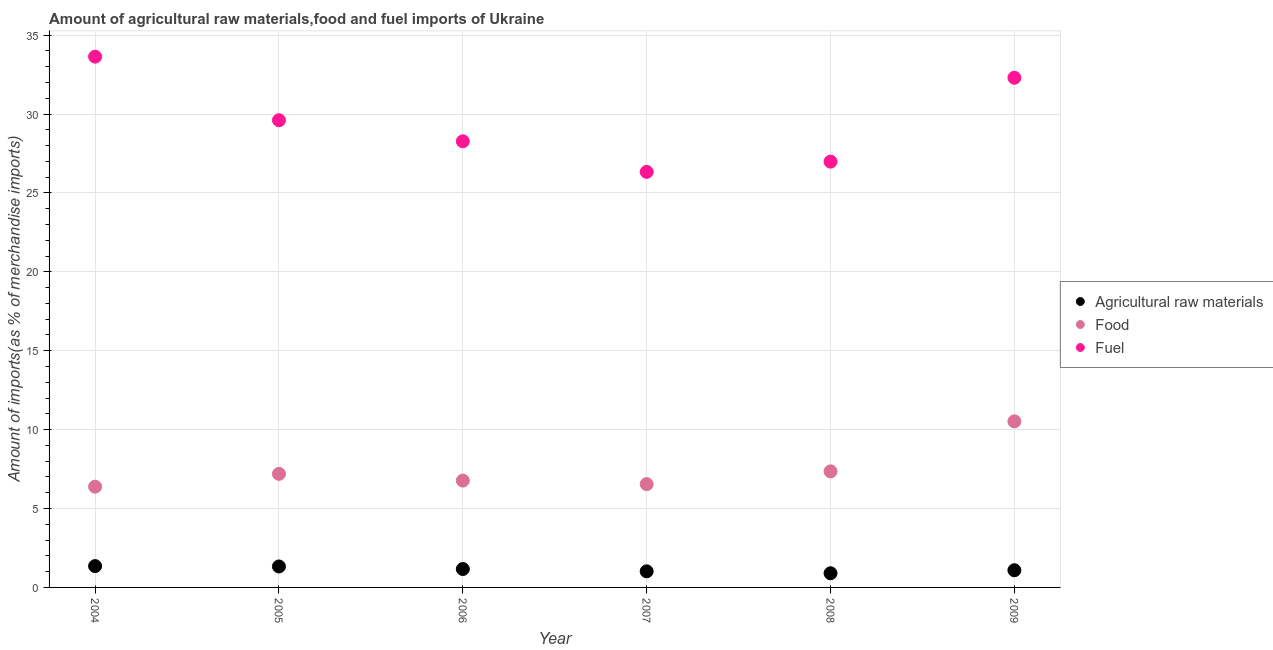What is the percentage of raw materials imports in 2006?
Keep it short and to the point. 1.17. Across all years, what is the maximum percentage of fuel imports?
Your response must be concise. 33.64. Across all years, what is the minimum percentage of food imports?
Ensure brevity in your answer.  6.39. In which year was the percentage of fuel imports maximum?
Make the answer very short. 2004. In which year was the percentage of fuel imports minimum?
Offer a very short reply. 2007. What is the total percentage of raw materials imports in the graph?
Give a very brief answer. 6.86. What is the difference between the percentage of fuel imports in 2006 and that in 2008?
Provide a succinct answer. 1.29. What is the difference between the percentage of fuel imports in 2006 and the percentage of food imports in 2004?
Offer a terse response. 21.89. What is the average percentage of fuel imports per year?
Make the answer very short. 29.52. In the year 2004, what is the difference between the percentage of food imports and percentage of fuel imports?
Give a very brief answer. -27.25. In how many years, is the percentage of food imports greater than 13 %?
Provide a succinct answer. 0. What is the ratio of the percentage of fuel imports in 2008 to that in 2009?
Your answer should be compact. 0.84. Is the percentage of fuel imports in 2008 less than that in 2009?
Offer a very short reply. Yes. What is the difference between the highest and the second highest percentage of raw materials imports?
Offer a very short reply. 0.02. What is the difference between the highest and the lowest percentage of fuel imports?
Ensure brevity in your answer.  7.3. Is the sum of the percentage of raw materials imports in 2007 and 2009 greater than the maximum percentage of fuel imports across all years?
Provide a succinct answer. No. Is it the case that in every year, the sum of the percentage of raw materials imports and percentage of food imports is greater than the percentage of fuel imports?
Provide a short and direct response. No. Does the percentage of raw materials imports monotonically increase over the years?
Make the answer very short. No. Is the percentage of raw materials imports strictly greater than the percentage of fuel imports over the years?
Ensure brevity in your answer.  No. Is the percentage of raw materials imports strictly less than the percentage of food imports over the years?
Offer a terse response. Yes. How many years are there in the graph?
Your response must be concise. 6. Does the graph contain any zero values?
Provide a succinct answer. No. Does the graph contain grids?
Ensure brevity in your answer.  Yes. Where does the legend appear in the graph?
Your answer should be very brief. Center right. How are the legend labels stacked?
Provide a succinct answer. Vertical. What is the title of the graph?
Ensure brevity in your answer.  Amount of agricultural raw materials,food and fuel imports of Ukraine. What is the label or title of the X-axis?
Make the answer very short. Year. What is the label or title of the Y-axis?
Provide a short and direct response. Amount of imports(as % of merchandise imports). What is the Amount of imports(as % of merchandise imports) in Agricultural raw materials in 2004?
Provide a short and direct response. 1.35. What is the Amount of imports(as % of merchandise imports) in Food in 2004?
Your response must be concise. 6.39. What is the Amount of imports(as % of merchandise imports) of Fuel in 2004?
Offer a terse response. 33.64. What is the Amount of imports(as % of merchandise imports) in Agricultural raw materials in 2005?
Provide a short and direct response. 1.33. What is the Amount of imports(as % of merchandise imports) of Food in 2005?
Offer a very short reply. 7.2. What is the Amount of imports(as % of merchandise imports) in Fuel in 2005?
Provide a short and direct response. 29.61. What is the Amount of imports(as % of merchandise imports) in Agricultural raw materials in 2006?
Offer a very short reply. 1.17. What is the Amount of imports(as % of merchandise imports) in Food in 2006?
Your answer should be compact. 6.77. What is the Amount of imports(as % of merchandise imports) of Fuel in 2006?
Your response must be concise. 28.27. What is the Amount of imports(as % of merchandise imports) of Agricultural raw materials in 2007?
Ensure brevity in your answer.  1.02. What is the Amount of imports(as % of merchandise imports) in Food in 2007?
Your answer should be very brief. 6.55. What is the Amount of imports(as % of merchandise imports) in Fuel in 2007?
Your answer should be compact. 26.33. What is the Amount of imports(as % of merchandise imports) of Agricultural raw materials in 2008?
Your response must be concise. 0.9. What is the Amount of imports(as % of merchandise imports) in Food in 2008?
Your answer should be very brief. 7.35. What is the Amount of imports(as % of merchandise imports) of Fuel in 2008?
Your answer should be very brief. 26.98. What is the Amount of imports(as % of merchandise imports) of Agricultural raw materials in 2009?
Your answer should be compact. 1.09. What is the Amount of imports(as % of merchandise imports) of Food in 2009?
Offer a very short reply. 10.52. What is the Amount of imports(as % of merchandise imports) in Fuel in 2009?
Your answer should be compact. 32.3. Across all years, what is the maximum Amount of imports(as % of merchandise imports) of Agricultural raw materials?
Offer a very short reply. 1.35. Across all years, what is the maximum Amount of imports(as % of merchandise imports) of Food?
Offer a very short reply. 10.52. Across all years, what is the maximum Amount of imports(as % of merchandise imports) in Fuel?
Provide a short and direct response. 33.64. Across all years, what is the minimum Amount of imports(as % of merchandise imports) of Agricultural raw materials?
Ensure brevity in your answer.  0.9. Across all years, what is the minimum Amount of imports(as % of merchandise imports) in Food?
Provide a short and direct response. 6.39. Across all years, what is the minimum Amount of imports(as % of merchandise imports) of Fuel?
Ensure brevity in your answer.  26.33. What is the total Amount of imports(as % of merchandise imports) of Agricultural raw materials in the graph?
Offer a very short reply. 6.86. What is the total Amount of imports(as % of merchandise imports) in Food in the graph?
Your answer should be compact. 44.78. What is the total Amount of imports(as % of merchandise imports) in Fuel in the graph?
Your answer should be compact. 177.13. What is the difference between the Amount of imports(as % of merchandise imports) of Agricultural raw materials in 2004 and that in 2005?
Give a very brief answer. 0.02. What is the difference between the Amount of imports(as % of merchandise imports) of Food in 2004 and that in 2005?
Offer a terse response. -0.81. What is the difference between the Amount of imports(as % of merchandise imports) of Fuel in 2004 and that in 2005?
Your response must be concise. 4.03. What is the difference between the Amount of imports(as % of merchandise imports) in Agricultural raw materials in 2004 and that in 2006?
Provide a short and direct response. 0.18. What is the difference between the Amount of imports(as % of merchandise imports) of Food in 2004 and that in 2006?
Provide a short and direct response. -0.39. What is the difference between the Amount of imports(as % of merchandise imports) in Fuel in 2004 and that in 2006?
Offer a very short reply. 5.36. What is the difference between the Amount of imports(as % of merchandise imports) of Agricultural raw materials in 2004 and that in 2007?
Ensure brevity in your answer.  0.33. What is the difference between the Amount of imports(as % of merchandise imports) in Food in 2004 and that in 2007?
Your answer should be very brief. -0.16. What is the difference between the Amount of imports(as % of merchandise imports) in Fuel in 2004 and that in 2007?
Give a very brief answer. 7.3. What is the difference between the Amount of imports(as % of merchandise imports) of Agricultural raw materials in 2004 and that in 2008?
Ensure brevity in your answer.  0.45. What is the difference between the Amount of imports(as % of merchandise imports) of Food in 2004 and that in 2008?
Your answer should be very brief. -0.97. What is the difference between the Amount of imports(as % of merchandise imports) in Fuel in 2004 and that in 2008?
Keep it short and to the point. 6.65. What is the difference between the Amount of imports(as % of merchandise imports) of Agricultural raw materials in 2004 and that in 2009?
Your answer should be very brief. 0.26. What is the difference between the Amount of imports(as % of merchandise imports) in Food in 2004 and that in 2009?
Your answer should be compact. -4.14. What is the difference between the Amount of imports(as % of merchandise imports) in Fuel in 2004 and that in 2009?
Your answer should be compact. 1.34. What is the difference between the Amount of imports(as % of merchandise imports) of Agricultural raw materials in 2005 and that in 2006?
Give a very brief answer. 0.16. What is the difference between the Amount of imports(as % of merchandise imports) of Food in 2005 and that in 2006?
Offer a very short reply. 0.43. What is the difference between the Amount of imports(as % of merchandise imports) of Fuel in 2005 and that in 2006?
Your answer should be compact. 1.34. What is the difference between the Amount of imports(as % of merchandise imports) of Agricultural raw materials in 2005 and that in 2007?
Your answer should be very brief. 0.31. What is the difference between the Amount of imports(as % of merchandise imports) in Food in 2005 and that in 2007?
Your answer should be compact. 0.65. What is the difference between the Amount of imports(as % of merchandise imports) in Fuel in 2005 and that in 2007?
Your answer should be compact. 3.27. What is the difference between the Amount of imports(as % of merchandise imports) in Agricultural raw materials in 2005 and that in 2008?
Your response must be concise. 0.43. What is the difference between the Amount of imports(as % of merchandise imports) of Food in 2005 and that in 2008?
Your answer should be very brief. -0.16. What is the difference between the Amount of imports(as % of merchandise imports) of Fuel in 2005 and that in 2008?
Offer a terse response. 2.62. What is the difference between the Amount of imports(as % of merchandise imports) in Agricultural raw materials in 2005 and that in 2009?
Ensure brevity in your answer.  0.24. What is the difference between the Amount of imports(as % of merchandise imports) in Food in 2005 and that in 2009?
Offer a terse response. -3.33. What is the difference between the Amount of imports(as % of merchandise imports) in Fuel in 2005 and that in 2009?
Your answer should be very brief. -2.69. What is the difference between the Amount of imports(as % of merchandise imports) of Agricultural raw materials in 2006 and that in 2007?
Give a very brief answer. 0.15. What is the difference between the Amount of imports(as % of merchandise imports) in Food in 2006 and that in 2007?
Make the answer very short. 0.22. What is the difference between the Amount of imports(as % of merchandise imports) in Fuel in 2006 and that in 2007?
Offer a terse response. 1.94. What is the difference between the Amount of imports(as % of merchandise imports) of Agricultural raw materials in 2006 and that in 2008?
Offer a terse response. 0.27. What is the difference between the Amount of imports(as % of merchandise imports) of Food in 2006 and that in 2008?
Your response must be concise. -0.58. What is the difference between the Amount of imports(as % of merchandise imports) of Fuel in 2006 and that in 2008?
Offer a terse response. 1.29. What is the difference between the Amount of imports(as % of merchandise imports) of Agricultural raw materials in 2006 and that in 2009?
Keep it short and to the point. 0.08. What is the difference between the Amount of imports(as % of merchandise imports) in Food in 2006 and that in 2009?
Keep it short and to the point. -3.75. What is the difference between the Amount of imports(as % of merchandise imports) of Fuel in 2006 and that in 2009?
Your response must be concise. -4.03. What is the difference between the Amount of imports(as % of merchandise imports) in Agricultural raw materials in 2007 and that in 2008?
Provide a succinct answer. 0.12. What is the difference between the Amount of imports(as % of merchandise imports) in Food in 2007 and that in 2008?
Your answer should be very brief. -0.81. What is the difference between the Amount of imports(as % of merchandise imports) in Fuel in 2007 and that in 2008?
Ensure brevity in your answer.  -0.65. What is the difference between the Amount of imports(as % of merchandise imports) of Agricultural raw materials in 2007 and that in 2009?
Give a very brief answer. -0.07. What is the difference between the Amount of imports(as % of merchandise imports) of Food in 2007 and that in 2009?
Offer a very short reply. -3.98. What is the difference between the Amount of imports(as % of merchandise imports) of Fuel in 2007 and that in 2009?
Your answer should be compact. -5.96. What is the difference between the Amount of imports(as % of merchandise imports) of Agricultural raw materials in 2008 and that in 2009?
Offer a very short reply. -0.19. What is the difference between the Amount of imports(as % of merchandise imports) of Food in 2008 and that in 2009?
Make the answer very short. -3.17. What is the difference between the Amount of imports(as % of merchandise imports) in Fuel in 2008 and that in 2009?
Provide a short and direct response. -5.31. What is the difference between the Amount of imports(as % of merchandise imports) of Agricultural raw materials in 2004 and the Amount of imports(as % of merchandise imports) of Food in 2005?
Your response must be concise. -5.85. What is the difference between the Amount of imports(as % of merchandise imports) in Agricultural raw materials in 2004 and the Amount of imports(as % of merchandise imports) in Fuel in 2005?
Provide a succinct answer. -28.26. What is the difference between the Amount of imports(as % of merchandise imports) of Food in 2004 and the Amount of imports(as % of merchandise imports) of Fuel in 2005?
Your answer should be very brief. -23.22. What is the difference between the Amount of imports(as % of merchandise imports) in Agricultural raw materials in 2004 and the Amount of imports(as % of merchandise imports) in Food in 2006?
Make the answer very short. -5.42. What is the difference between the Amount of imports(as % of merchandise imports) of Agricultural raw materials in 2004 and the Amount of imports(as % of merchandise imports) of Fuel in 2006?
Make the answer very short. -26.92. What is the difference between the Amount of imports(as % of merchandise imports) in Food in 2004 and the Amount of imports(as % of merchandise imports) in Fuel in 2006?
Provide a succinct answer. -21.89. What is the difference between the Amount of imports(as % of merchandise imports) of Agricultural raw materials in 2004 and the Amount of imports(as % of merchandise imports) of Food in 2007?
Your answer should be very brief. -5.2. What is the difference between the Amount of imports(as % of merchandise imports) in Agricultural raw materials in 2004 and the Amount of imports(as % of merchandise imports) in Fuel in 2007?
Your response must be concise. -24.98. What is the difference between the Amount of imports(as % of merchandise imports) in Food in 2004 and the Amount of imports(as % of merchandise imports) in Fuel in 2007?
Give a very brief answer. -19.95. What is the difference between the Amount of imports(as % of merchandise imports) in Agricultural raw materials in 2004 and the Amount of imports(as % of merchandise imports) in Food in 2008?
Provide a succinct answer. -6. What is the difference between the Amount of imports(as % of merchandise imports) of Agricultural raw materials in 2004 and the Amount of imports(as % of merchandise imports) of Fuel in 2008?
Keep it short and to the point. -25.63. What is the difference between the Amount of imports(as % of merchandise imports) of Food in 2004 and the Amount of imports(as % of merchandise imports) of Fuel in 2008?
Keep it short and to the point. -20.6. What is the difference between the Amount of imports(as % of merchandise imports) in Agricultural raw materials in 2004 and the Amount of imports(as % of merchandise imports) in Food in 2009?
Your answer should be compact. -9.17. What is the difference between the Amount of imports(as % of merchandise imports) of Agricultural raw materials in 2004 and the Amount of imports(as % of merchandise imports) of Fuel in 2009?
Give a very brief answer. -30.95. What is the difference between the Amount of imports(as % of merchandise imports) of Food in 2004 and the Amount of imports(as % of merchandise imports) of Fuel in 2009?
Offer a terse response. -25.91. What is the difference between the Amount of imports(as % of merchandise imports) in Agricultural raw materials in 2005 and the Amount of imports(as % of merchandise imports) in Food in 2006?
Provide a short and direct response. -5.44. What is the difference between the Amount of imports(as % of merchandise imports) in Agricultural raw materials in 2005 and the Amount of imports(as % of merchandise imports) in Fuel in 2006?
Provide a succinct answer. -26.94. What is the difference between the Amount of imports(as % of merchandise imports) of Food in 2005 and the Amount of imports(as % of merchandise imports) of Fuel in 2006?
Ensure brevity in your answer.  -21.07. What is the difference between the Amount of imports(as % of merchandise imports) of Agricultural raw materials in 2005 and the Amount of imports(as % of merchandise imports) of Food in 2007?
Make the answer very short. -5.22. What is the difference between the Amount of imports(as % of merchandise imports) in Agricultural raw materials in 2005 and the Amount of imports(as % of merchandise imports) in Fuel in 2007?
Provide a short and direct response. -25. What is the difference between the Amount of imports(as % of merchandise imports) in Food in 2005 and the Amount of imports(as % of merchandise imports) in Fuel in 2007?
Your answer should be compact. -19.14. What is the difference between the Amount of imports(as % of merchandise imports) of Agricultural raw materials in 2005 and the Amount of imports(as % of merchandise imports) of Food in 2008?
Ensure brevity in your answer.  -6.03. What is the difference between the Amount of imports(as % of merchandise imports) in Agricultural raw materials in 2005 and the Amount of imports(as % of merchandise imports) in Fuel in 2008?
Give a very brief answer. -25.66. What is the difference between the Amount of imports(as % of merchandise imports) of Food in 2005 and the Amount of imports(as % of merchandise imports) of Fuel in 2008?
Your answer should be compact. -19.79. What is the difference between the Amount of imports(as % of merchandise imports) in Agricultural raw materials in 2005 and the Amount of imports(as % of merchandise imports) in Food in 2009?
Ensure brevity in your answer.  -9.2. What is the difference between the Amount of imports(as % of merchandise imports) of Agricultural raw materials in 2005 and the Amount of imports(as % of merchandise imports) of Fuel in 2009?
Make the answer very short. -30.97. What is the difference between the Amount of imports(as % of merchandise imports) of Food in 2005 and the Amount of imports(as % of merchandise imports) of Fuel in 2009?
Your response must be concise. -25.1. What is the difference between the Amount of imports(as % of merchandise imports) in Agricultural raw materials in 2006 and the Amount of imports(as % of merchandise imports) in Food in 2007?
Give a very brief answer. -5.38. What is the difference between the Amount of imports(as % of merchandise imports) of Agricultural raw materials in 2006 and the Amount of imports(as % of merchandise imports) of Fuel in 2007?
Make the answer very short. -25.17. What is the difference between the Amount of imports(as % of merchandise imports) in Food in 2006 and the Amount of imports(as % of merchandise imports) in Fuel in 2007?
Provide a succinct answer. -19.56. What is the difference between the Amount of imports(as % of merchandise imports) in Agricultural raw materials in 2006 and the Amount of imports(as % of merchandise imports) in Food in 2008?
Keep it short and to the point. -6.19. What is the difference between the Amount of imports(as % of merchandise imports) in Agricultural raw materials in 2006 and the Amount of imports(as % of merchandise imports) in Fuel in 2008?
Your answer should be very brief. -25.82. What is the difference between the Amount of imports(as % of merchandise imports) of Food in 2006 and the Amount of imports(as % of merchandise imports) of Fuel in 2008?
Ensure brevity in your answer.  -20.21. What is the difference between the Amount of imports(as % of merchandise imports) of Agricultural raw materials in 2006 and the Amount of imports(as % of merchandise imports) of Food in 2009?
Your response must be concise. -9.36. What is the difference between the Amount of imports(as % of merchandise imports) of Agricultural raw materials in 2006 and the Amount of imports(as % of merchandise imports) of Fuel in 2009?
Offer a very short reply. -31.13. What is the difference between the Amount of imports(as % of merchandise imports) of Food in 2006 and the Amount of imports(as % of merchandise imports) of Fuel in 2009?
Your response must be concise. -25.53. What is the difference between the Amount of imports(as % of merchandise imports) of Agricultural raw materials in 2007 and the Amount of imports(as % of merchandise imports) of Food in 2008?
Your response must be concise. -6.33. What is the difference between the Amount of imports(as % of merchandise imports) of Agricultural raw materials in 2007 and the Amount of imports(as % of merchandise imports) of Fuel in 2008?
Offer a terse response. -25.96. What is the difference between the Amount of imports(as % of merchandise imports) of Food in 2007 and the Amount of imports(as % of merchandise imports) of Fuel in 2008?
Your answer should be compact. -20.44. What is the difference between the Amount of imports(as % of merchandise imports) in Agricultural raw materials in 2007 and the Amount of imports(as % of merchandise imports) in Food in 2009?
Give a very brief answer. -9.5. What is the difference between the Amount of imports(as % of merchandise imports) in Agricultural raw materials in 2007 and the Amount of imports(as % of merchandise imports) in Fuel in 2009?
Provide a short and direct response. -31.28. What is the difference between the Amount of imports(as % of merchandise imports) in Food in 2007 and the Amount of imports(as % of merchandise imports) in Fuel in 2009?
Your response must be concise. -25.75. What is the difference between the Amount of imports(as % of merchandise imports) of Agricultural raw materials in 2008 and the Amount of imports(as % of merchandise imports) of Food in 2009?
Provide a short and direct response. -9.63. What is the difference between the Amount of imports(as % of merchandise imports) in Agricultural raw materials in 2008 and the Amount of imports(as % of merchandise imports) in Fuel in 2009?
Provide a succinct answer. -31.4. What is the difference between the Amount of imports(as % of merchandise imports) of Food in 2008 and the Amount of imports(as % of merchandise imports) of Fuel in 2009?
Your answer should be very brief. -24.94. What is the average Amount of imports(as % of merchandise imports) of Agricultural raw materials per year?
Provide a short and direct response. 1.14. What is the average Amount of imports(as % of merchandise imports) in Food per year?
Offer a very short reply. 7.46. What is the average Amount of imports(as % of merchandise imports) in Fuel per year?
Give a very brief answer. 29.52. In the year 2004, what is the difference between the Amount of imports(as % of merchandise imports) in Agricultural raw materials and Amount of imports(as % of merchandise imports) in Food?
Provide a succinct answer. -5.03. In the year 2004, what is the difference between the Amount of imports(as % of merchandise imports) of Agricultural raw materials and Amount of imports(as % of merchandise imports) of Fuel?
Offer a very short reply. -32.28. In the year 2004, what is the difference between the Amount of imports(as % of merchandise imports) in Food and Amount of imports(as % of merchandise imports) in Fuel?
Your response must be concise. -27.25. In the year 2005, what is the difference between the Amount of imports(as % of merchandise imports) of Agricultural raw materials and Amount of imports(as % of merchandise imports) of Food?
Provide a short and direct response. -5.87. In the year 2005, what is the difference between the Amount of imports(as % of merchandise imports) of Agricultural raw materials and Amount of imports(as % of merchandise imports) of Fuel?
Keep it short and to the point. -28.28. In the year 2005, what is the difference between the Amount of imports(as % of merchandise imports) in Food and Amount of imports(as % of merchandise imports) in Fuel?
Offer a terse response. -22.41. In the year 2006, what is the difference between the Amount of imports(as % of merchandise imports) in Agricultural raw materials and Amount of imports(as % of merchandise imports) in Food?
Your response must be concise. -5.6. In the year 2006, what is the difference between the Amount of imports(as % of merchandise imports) in Agricultural raw materials and Amount of imports(as % of merchandise imports) in Fuel?
Your response must be concise. -27.1. In the year 2006, what is the difference between the Amount of imports(as % of merchandise imports) in Food and Amount of imports(as % of merchandise imports) in Fuel?
Offer a very short reply. -21.5. In the year 2007, what is the difference between the Amount of imports(as % of merchandise imports) of Agricultural raw materials and Amount of imports(as % of merchandise imports) of Food?
Give a very brief answer. -5.53. In the year 2007, what is the difference between the Amount of imports(as % of merchandise imports) in Agricultural raw materials and Amount of imports(as % of merchandise imports) in Fuel?
Your response must be concise. -25.31. In the year 2007, what is the difference between the Amount of imports(as % of merchandise imports) of Food and Amount of imports(as % of merchandise imports) of Fuel?
Your answer should be compact. -19.79. In the year 2008, what is the difference between the Amount of imports(as % of merchandise imports) of Agricultural raw materials and Amount of imports(as % of merchandise imports) of Food?
Your answer should be compact. -6.46. In the year 2008, what is the difference between the Amount of imports(as % of merchandise imports) of Agricultural raw materials and Amount of imports(as % of merchandise imports) of Fuel?
Keep it short and to the point. -26.08. In the year 2008, what is the difference between the Amount of imports(as % of merchandise imports) in Food and Amount of imports(as % of merchandise imports) in Fuel?
Make the answer very short. -19.63. In the year 2009, what is the difference between the Amount of imports(as % of merchandise imports) of Agricultural raw materials and Amount of imports(as % of merchandise imports) of Food?
Offer a terse response. -9.43. In the year 2009, what is the difference between the Amount of imports(as % of merchandise imports) of Agricultural raw materials and Amount of imports(as % of merchandise imports) of Fuel?
Keep it short and to the point. -31.21. In the year 2009, what is the difference between the Amount of imports(as % of merchandise imports) in Food and Amount of imports(as % of merchandise imports) in Fuel?
Your answer should be very brief. -21.77. What is the ratio of the Amount of imports(as % of merchandise imports) in Agricultural raw materials in 2004 to that in 2005?
Your response must be concise. 1.02. What is the ratio of the Amount of imports(as % of merchandise imports) of Food in 2004 to that in 2005?
Your answer should be very brief. 0.89. What is the ratio of the Amount of imports(as % of merchandise imports) in Fuel in 2004 to that in 2005?
Give a very brief answer. 1.14. What is the ratio of the Amount of imports(as % of merchandise imports) in Agricultural raw materials in 2004 to that in 2006?
Give a very brief answer. 1.16. What is the ratio of the Amount of imports(as % of merchandise imports) in Food in 2004 to that in 2006?
Give a very brief answer. 0.94. What is the ratio of the Amount of imports(as % of merchandise imports) in Fuel in 2004 to that in 2006?
Offer a terse response. 1.19. What is the ratio of the Amount of imports(as % of merchandise imports) of Agricultural raw materials in 2004 to that in 2007?
Offer a very short reply. 1.32. What is the ratio of the Amount of imports(as % of merchandise imports) in Food in 2004 to that in 2007?
Your response must be concise. 0.98. What is the ratio of the Amount of imports(as % of merchandise imports) in Fuel in 2004 to that in 2007?
Your response must be concise. 1.28. What is the ratio of the Amount of imports(as % of merchandise imports) of Agricultural raw materials in 2004 to that in 2008?
Ensure brevity in your answer.  1.5. What is the ratio of the Amount of imports(as % of merchandise imports) of Food in 2004 to that in 2008?
Your response must be concise. 0.87. What is the ratio of the Amount of imports(as % of merchandise imports) of Fuel in 2004 to that in 2008?
Your response must be concise. 1.25. What is the ratio of the Amount of imports(as % of merchandise imports) in Agricultural raw materials in 2004 to that in 2009?
Provide a succinct answer. 1.24. What is the ratio of the Amount of imports(as % of merchandise imports) of Food in 2004 to that in 2009?
Provide a succinct answer. 0.61. What is the ratio of the Amount of imports(as % of merchandise imports) in Fuel in 2004 to that in 2009?
Your response must be concise. 1.04. What is the ratio of the Amount of imports(as % of merchandise imports) of Agricultural raw materials in 2005 to that in 2006?
Offer a terse response. 1.14. What is the ratio of the Amount of imports(as % of merchandise imports) in Food in 2005 to that in 2006?
Keep it short and to the point. 1.06. What is the ratio of the Amount of imports(as % of merchandise imports) of Fuel in 2005 to that in 2006?
Your response must be concise. 1.05. What is the ratio of the Amount of imports(as % of merchandise imports) in Agricultural raw materials in 2005 to that in 2007?
Provide a succinct answer. 1.3. What is the ratio of the Amount of imports(as % of merchandise imports) in Food in 2005 to that in 2007?
Your answer should be compact. 1.1. What is the ratio of the Amount of imports(as % of merchandise imports) in Fuel in 2005 to that in 2007?
Provide a short and direct response. 1.12. What is the ratio of the Amount of imports(as % of merchandise imports) of Agricultural raw materials in 2005 to that in 2008?
Your answer should be very brief. 1.48. What is the ratio of the Amount of imports(as % of merchandise imports) in Food in 2005 to that in 2008?
Offer a very short reply. 0.98. What is the ratio of the Amount of imports(as % of merchandise imports) of Fuel in 2005 to that in 2008?
Keep it short and to the point. 1.1. What is the ratio of the Amount of imports(as % of merchandise imports) of Agricultural raw materials in 2005 to that in 2009?
Your response must be concise. 1.22. What is the ratio of the Amount of imports(as % of merchandise imports) in Food in 2005 to that in 2009?
Give a very brief answer. 0.68. What is the ratio of the Amount of imports(as % of merchandise imports) of Fuel in 2005 to that in 2009?
Offer a terse response. 0.92. What is the ratio of the Amount of imports(as % of merchandise imports) of Agricultural raw materials in 2006 to that in 2007?
Give a very brief answer. 1.14. What is the ratio of the Amount of imports(as % of merchandise imports) in Food in 2006 to that in 2007?
Your answer should be compact. 1.03. What is the ratio of the Amount of imports(as % of merchandise imports) of Fuel in 2006 to that in 2007?
Ensure brevity in your answer.  1.07. What is the ratio of the Amount of imports(as % of merchandise imports) of Agricultural raw materials in 2006 to that in 2008?
Offer a terse response. 1.3. What is the ratio of the Amount of imports(as % of merchandise imports) of Food in 2006 to that in 2008?
Provide a succinct answer. 0.92. What is the ratio of the Amount of imports(as % of merchandise imports) in Fuel in 2006 to that in 2008?
Your answer should be very brief. 1.05. What is the ratio of the Amount of imports(as % of merchandise imports) of Agricultural raw materials in 2006 to that in 2009?
Offer a terse response. 1.07. What is the ratio of the Amount of imports(as % of merchandise imports) of Food in 2006 to that in 2009?
Provide a succinct answer. 0.64. What is the ratio of the Amount of imports(as % of merchandise imports) of Fuel in 2006 to that in 2009?
Your answer should be compact. 0.88. What is the ratio of the Amount of imports(as % of merchandise imports) in Agricultural raw materials in 2007 to that in 2008?
Provide a succinct answer. 1.14. What is the ratio of the Amount of imports(as % of merchandise imports) of Food in 2007 to that in 2008?
Give a very brief answer. 0.89. What is the ratio of the Amount of imports(as % of merchandise imports) of Fuel in 2007 to that in 2008?
Your answer should be very brief. 0.98. What is the ratio of the Amount of imports(as % of merchandise imports) in Agricultural raw materials in 2007 to that in 2009?
Keep it short and to the point. 0.94. What is the ratio of the Amount of imports(as % of merchandise imports) of Food in 2007 to that in 2009?
Offer a very short reply. 0.62. What is the ratio of the Amount of imports(as % of merchandise imports) in Fuel in 2007 to that in 2009?
Your response must be concise. 0.82. What is the ratio of the Amount of imports(as % of merchandise imports) in Agricultural raw materials in 2008 to that in 2009?
Provide a succinct answer. 0.82. What is the ratio of the Amount of imports(as % of merchandise imports) of Food in 2008 to that in 2009?
Make the answer very short. 0.7. What is the ratio of the Amount of imports(as % of merchandise imports) in Fuel in 2008 to that in 2009?
Provide a short and direct response. 0.84. What is the difference between the highest and the second highest Amount of imports(as % of merchandise imports) in Agricultural raw materials?
Offer a terse response. 0.02. What is the difference between the highest and the second highest Amount of imports(as % of merchandise imports) of Food?
Offer a terse response. 3.17. What is the difference between the highest and the second highest Amount of imports(as % of merchandise imports) of Fuel?
Provide a succinct answer. 1.34. What is the difference between the highest and the lowest Amount of imports(as % of merchandise imports) of Agricultural raw materials?
Provide a succinct answer. 0.45. What is the difference between the highest and the lowest Amount of imports(as % of merchandise imports) of Food?
Offer a terse response. 4.14. What is the difference between the highest and the lowest Amount of imports(as % of merchandise imports) of Fuel?
Your response must be concise. 7.3. 